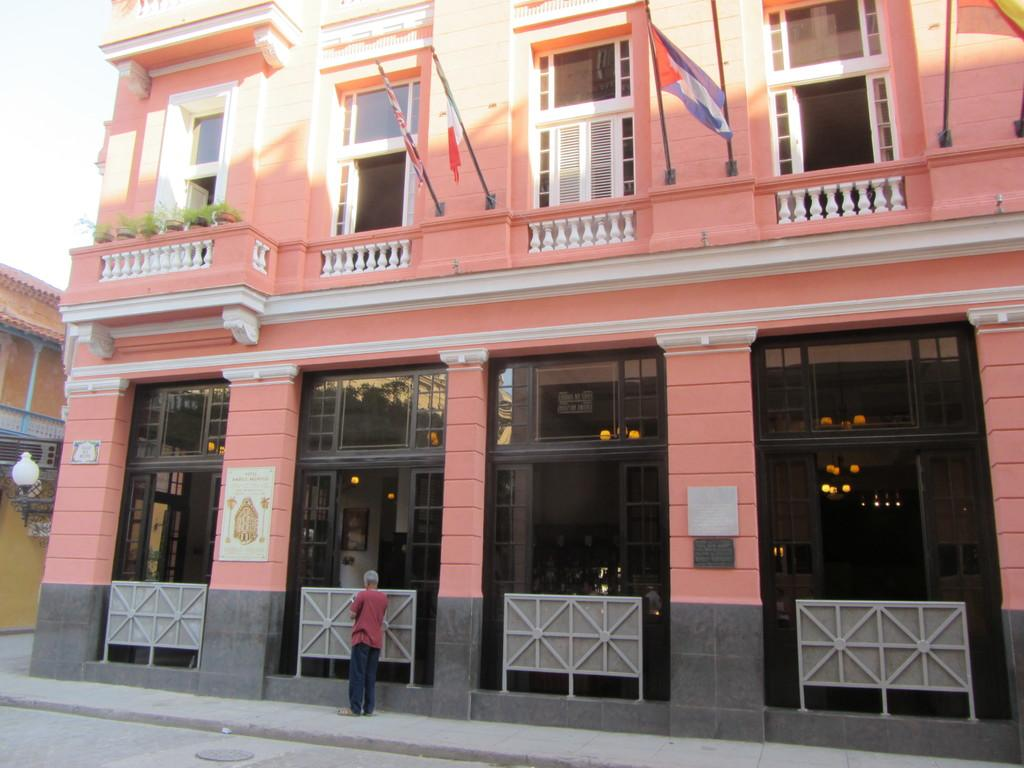What type of structure is present in the image? There is a building with windows in the image. Can you describe any people or objects in the image? A person is visible in the image. What else can be seen in the image besides the building and person? There are plants and flags in the image. Are there any additional features on the building? Yes, a light is attached to the building. What brand of toothpaste is being advertised on the building in the image? There is no toothpaste or advertisement present in the image. Can you hear any thunder in the image? The image is silent, and there is no indication of thunder or any sound. 